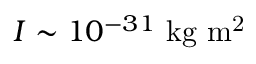Convert formula to latex. <formula><loc_0><loc_0><loc_500><loc_500>I \sim 1 0 ^ { - 3 1 } k g m ^ { 2 }</formula> 